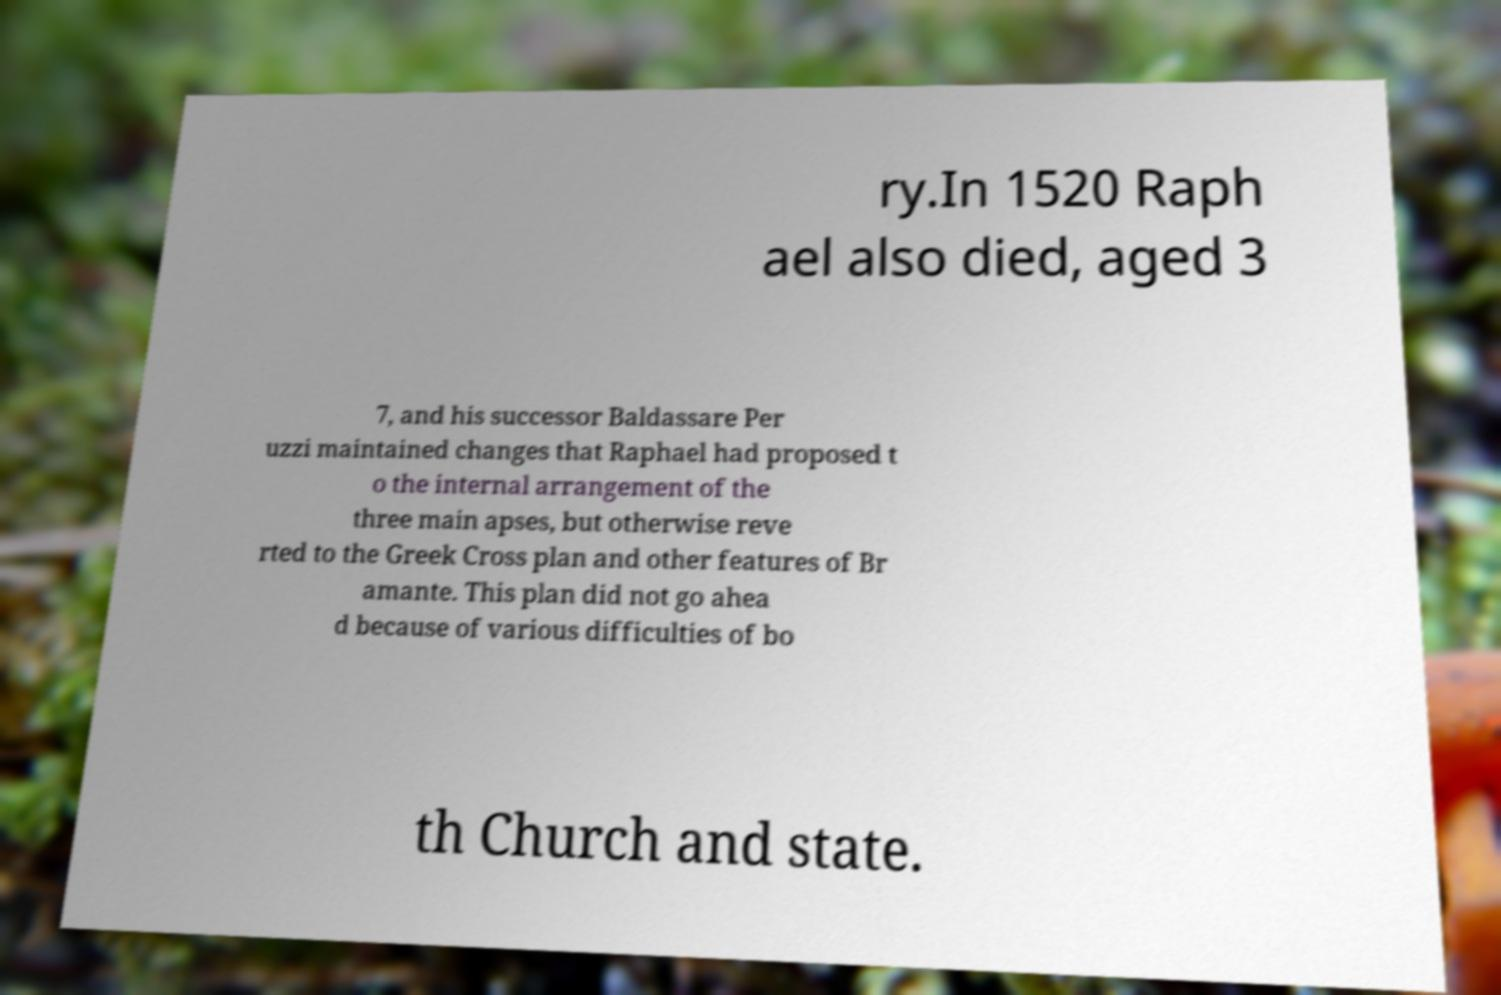What messages or text are displayed in this image? I need them in a readable, typed format. ry.In 1520 Raph ael also died, aged 3 7, and his successor Baldassare Per uzzi maintained changes that Raphael had proposed t o the internal arrangement of the three main apses, but otherwise reve rted to the Greek Cross plan and other features of Br amante. This plan did not go ahea d because of various difficulties of bo th Church and state. 